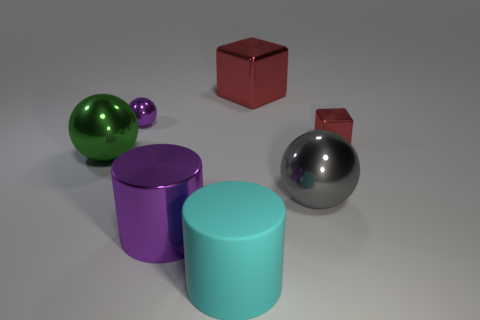Add 2 big cyan rubber things. How many objects exist? 9 Subtract all cubes. How many objects are left? 5 Subtract 0 green cylinders. How many objects are left? 7 Subtract all metallic objects. Subtract all small cubes. How many objects are left? 0 Add 7 purple shiny spheres. How many purple shiny spheres are left? 8 Add 5 big red cubes. How many big red cubes exist? 6 